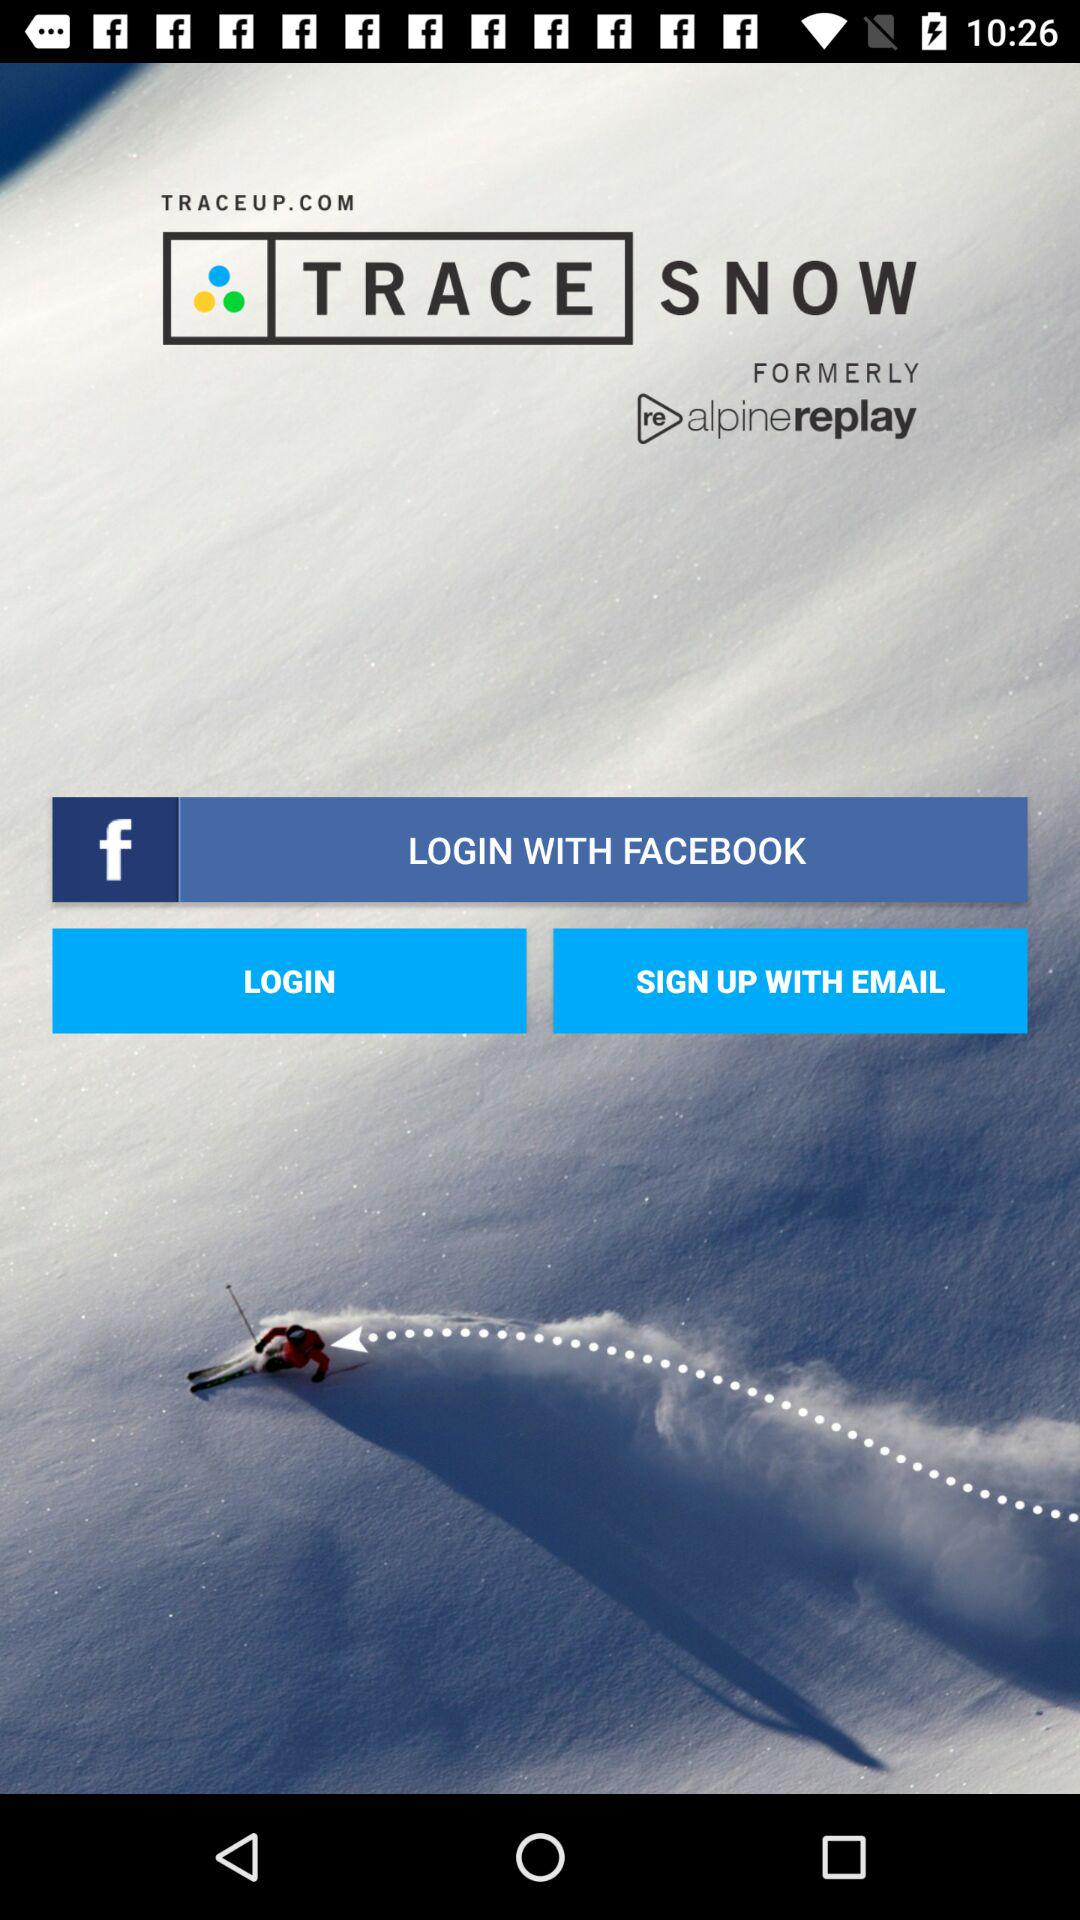What are the available options for logging in? The available option is "FACEBOOK". 